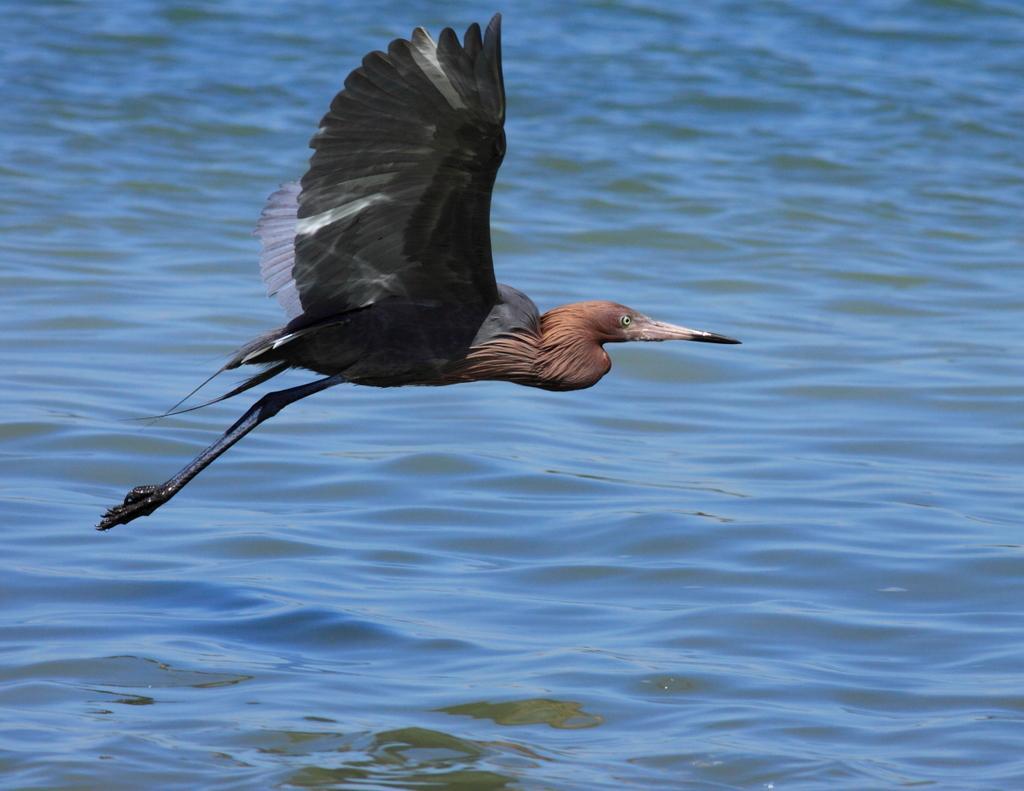Could you give a brief overview of what you see in this image? In this picture I can observe a bird flying in the air in the middle of the picture. In the background I can observe water. 